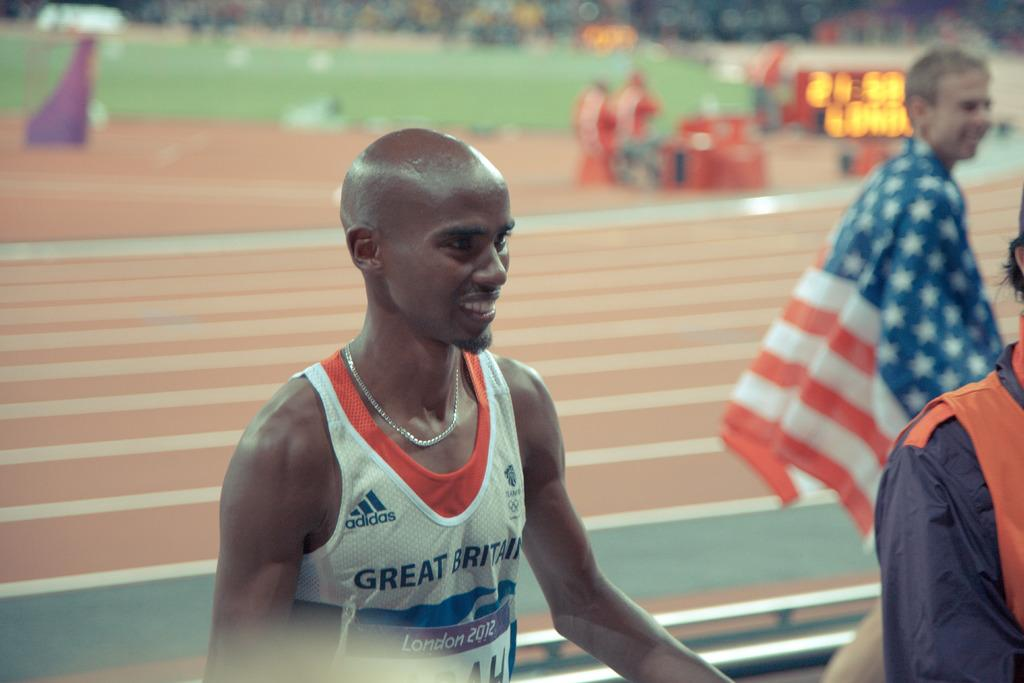Provide a one-sentence caption for the provided image. Runner wearing Great Britain shirt with a London 2012 race bib. 